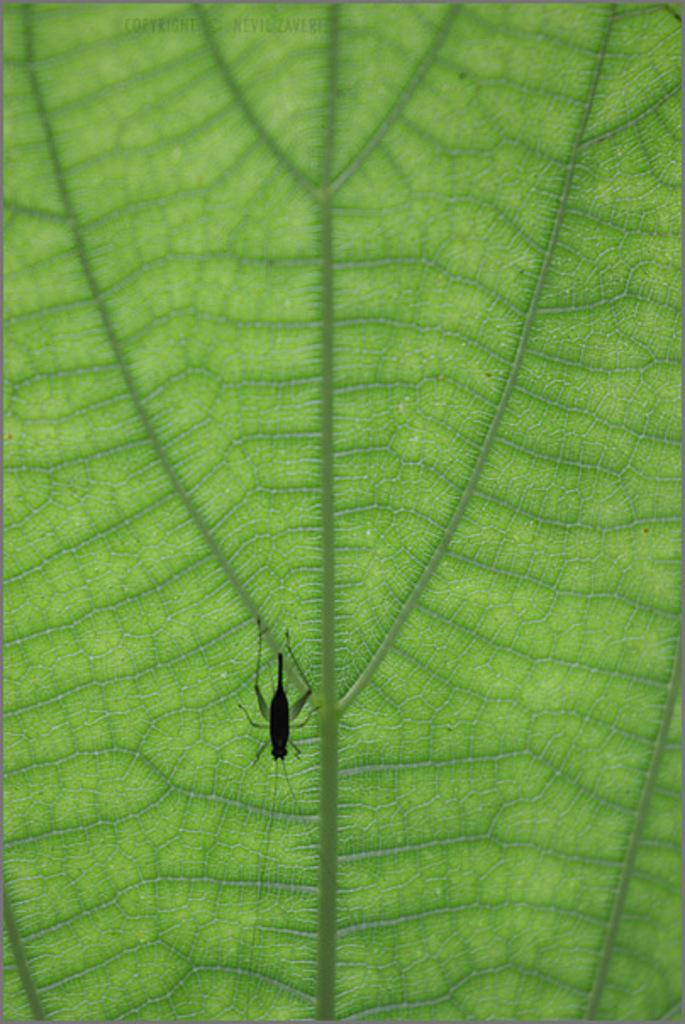What type of insect can be seen on the leaf in the image? There is a black color insect on a leaf in the image. What is the color of the insect? The insect is black. Can you describe the background of the image? The background of the image is a leaf. What is visible at the top of the image? There is text visible at the top of the image. What type of stove is present in the image? There is no stove present in the image; it features a black color insect on a leaf and text at the top. Can you tell me how many fans are visible in the image? There are no fans present in the image. 